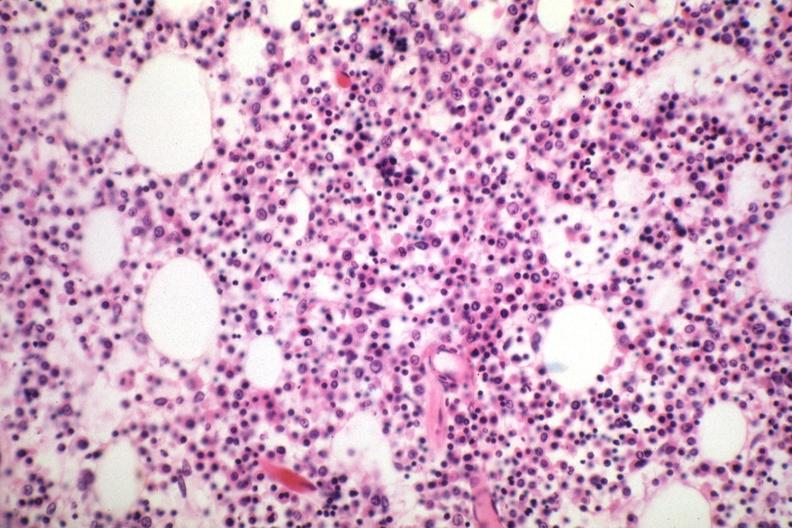does disease show marrow loaded with plasma cells that are immature?
Answer the question using a single word or phrase. No 